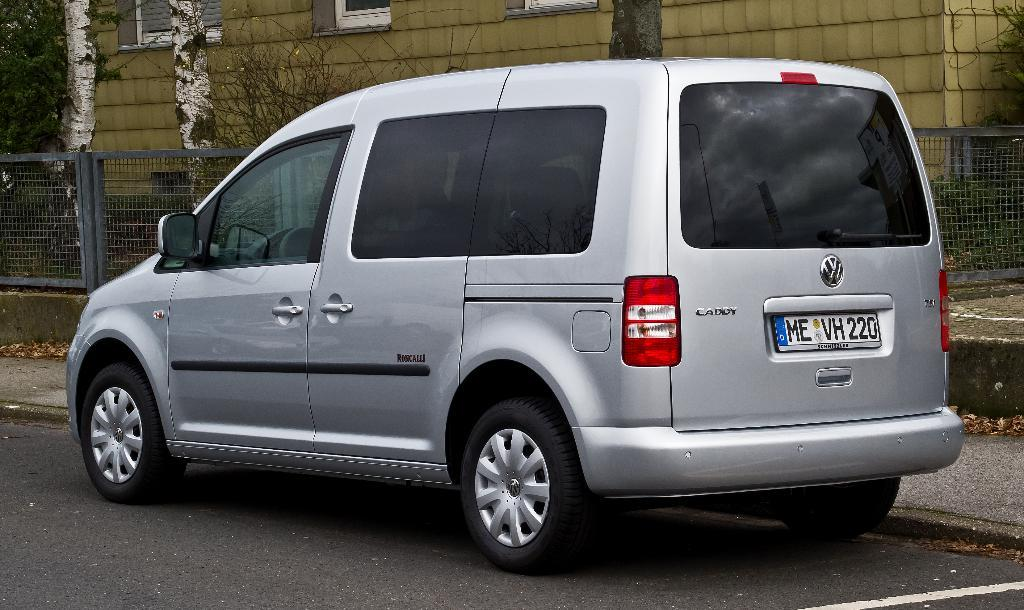What is on the road in the image? There is a vehicle on the road in the image. What can be seen on the road besides the vehicle? The road is visible in the image, and there is a white line on the road. What type of path is present in the image? There is a footpath in the image. What is present on the ground near the footpath? Dry leaves are present in the image. What separates the road from the footpath? There is a fence in the image. What is visible in the background of the image? A tree trunk and a building are visible in the image. What can be seen on the building? Windows are present on the building. How does the user rub the tongue in the image? There is no mention of a user or a tongue in the image; it only features a vehicle, road, white line, footpath, dry leaves, fence, tree trunk, building, and windows. 